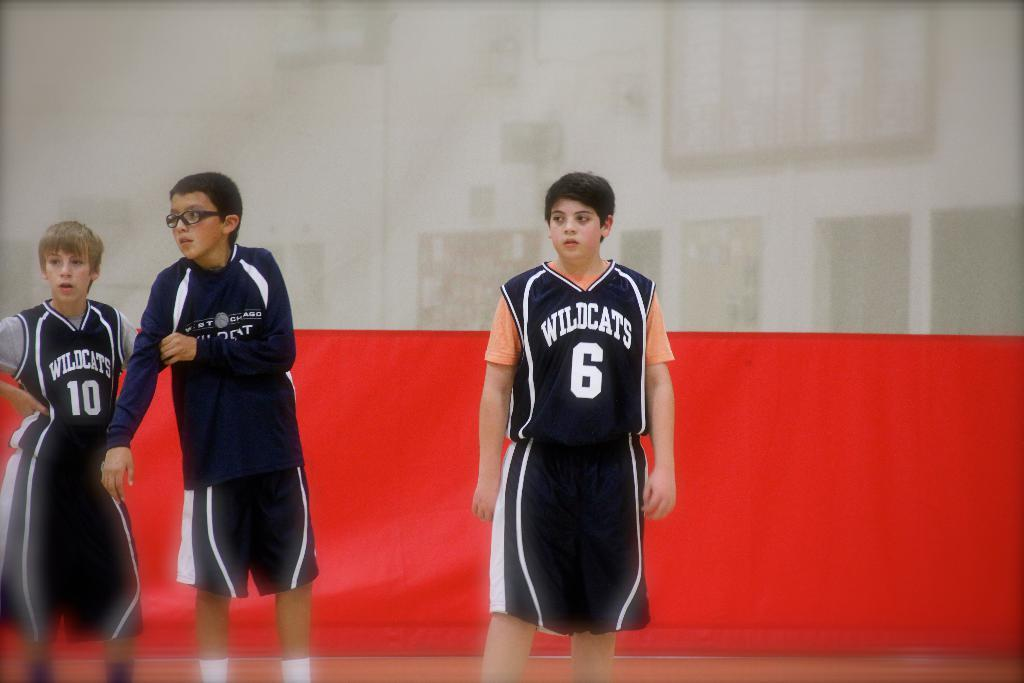<image>
Present a compact description of the photo's key features. Basketball player wearing number 6 standing and watching the game. 